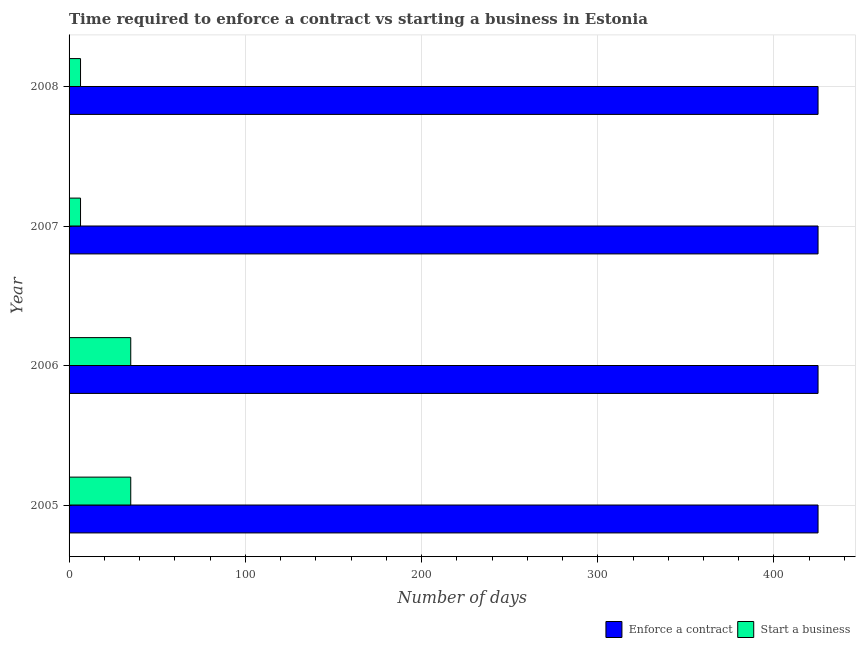How many different coloured bars are there?
Keep it short and to the point. 2. Are the number of bars per tick equal to the number of legend labels?
Make the answer very short. Yes. Are the number of bars on each tick of the Y-axis equal?
Make the answer very short. Yes. How many bars are there on the 3rd tick from the top?
Provide a succinct answer. 2. In how many cases, is the number of bars for a given year not equal to the number of legend labels?
Your response must be concise. 0. What is the number of days to enforece a contract in 2008?
Give a very brief answer. 425. Across all years, what is the maximum number of days to start a business?
Your answer should be very brief. 35. In which year was the number of days to start a business maximum?
Offer a terse response. 2005. What is the total number of days to enforece a contract in the graph?
Offer a very short reply. 1700. What is the difference between the number of days to start a business in 2007 and that in 2008?
Offer a very short reply. 0. What is the difference between the number of days to start a business in 2006 and the number of days to enforece a contract in 2005?
Give a very brief answer. -390. What is the average number of days to start a business per year?
Ensure brevity in your answer.  20.75. In the year 2005, what is the difference between the number of days to enforece a contract and number of days to start a business?
Your answer should be compact. 390. What is the ratio of the number of days to start a business in 2005 to that in 2008?
Provide a short and direct response. 5.38. In how many years, is the number of days to enforece a contract greater than the average number of days to enforece a contract taken over all years?
Give a very brief answer. 0. What does the 2nd bar from the top in 2007 represents?
Provide a short and direct response. Enforce a contract. What does the 2nd bar from the bottom in 2006 represents?
Provide a short and direct response. Start a business. How many bars are there?
Your response must be concise. 8. Are all the bars in the graph horizontal?
Offer a very short reply. Yes. How many years are there in the graph?
Your answer should be compact. 4. What is the difference between two consecutive major ticks on the X-axis?
Offer a very short reply. 100. Are the values on the major ticks of X-axis written in scientific E-notation?
Give a very brief answer. No. Does the graph contain any zero values?
Provide a succinct answer. No. Does the graph contain grids?
Your answer should be very brief. Yes. How many legend labels are there?
Your response must be concise. 2. How are the legend labels stacked?
Give a very brief answer. Horizontal. What is the title of the graph?
Your response must be concise. Time required to enforce a contract vs starting a business in Estonia. What is the label or title of the X-axis?
Provide a short and direct response. Number of days. What is the label or title of the Y-axis?
Give a very brief answer. Year. What is the Number of days of Enforce a contract in 2005?
Make the answer very short. 425. What is the Number of days of Enforce a contract in 2006?
Make the answer very short. 425. What is the Number of days in Start a business in 2006?
Keep it short and to the point. 35. What is the Number of days of Enforce a contract in 2007?
Your answer should be very brief. 425. What is the Number of days of Enforce a contract in 2008?
Your answer should be very brief. 425. What is the Number of days in Start a business in 2008?
Your response must be concise. 6.5. Across all years, what is the maximum Number of days of Enforce a contract?
Offer a terse response. 425. Across all years, what is the minimum Number of days in Enforce a contract?
Your answer should be compact. 425. Across all years, what is the minimum Number of days of Start a business?
Make the answer very short. 6.5. What is the total Number of days in Enforce a contract in the graph?
Give a very brief answer. 1700. What is the difference between the Number of days in Enforce a contract in 2005 and that in 2006?
Offer a very short reply. 0. What is the difference between the Number of days in Start a business in 2005 and that in 2006?
Offer a terse response. 0. What is the difference between the Number of days in Start a business in 2005 and that in 2007?
Ensure brevity in your answer.  28.5. What is the difference between the Number of days of Enforce a contract in 2005 and that in 2008?
Your answer should be compact. 0. What is the difference between the Number of days in Enforce a contract in 2006 and that in 2007?
Provide a succinct answer. 0. What is the difference between the Number of days of Enforce a contract in 2006 and that in 2008?
Your answer should be very brief. 0. What is the difference between the Number of days of Start a business in 2006 and that in 2008?
Your answer should be very brief. 28.5. What is the difference between the Number of days of Enforce a contract in 2007 and that in 2008?
Make the answer very short. 0. What is the difference between the Number of days of Start a business in 2007 and that in 2008?
Your response must be concise. 0. What is the difference between the Number of days in Enforce a contract in 2005 and the Number of days in Start a business in 2006?
Your answer should be compact. 390. What is the difference between the Number of days in Enforce a contract in 2005 and the Number of days in Start a business in 2007?
Keep it short and to the point. 418.5. What is the difference between the Number of days in Enforce a contract in 2005 and the Number of days in Start a business in 2008?
Your response must be concise. 418.5. What is the difference between the Number of days in Enforce a contract in 2006 and the Number of days in Start a business in 2007?
Ensure brevity in your answer.  418.5. What is the difference between the Number of days of Enforce a contract in 2006 and the Number of days of Start a business in 2008?
Provide a succinct answer. 418.5. What is the difference between the Number of days of Enforce a contract in 2007 and the Number of days of Start a business in 2008?
Your answer should be very brief. 418.5. What is the average Number of days in Enforce a contract per year?
Your response must be concise. 425. What is the average Number of days of Start a business per year?
Your answer should be compact. 20.75. In the year 2005, what is the difference between the Number of days of Enforce a contract and Number of days of Start a business?
Offer a terse response. 390. In the year 2006, what is the difference between the Number of days of Enforce a contract and Number of days of Start a business?
Provide a short and direct response. 390. In the year 2007, what is the difference between the Number of days of Enforce a contract and Number of days of Start a business?
Keep it short and to the point. 418.5. In the year 2008, what is the difference between the Number of days of Enforce a contract and Number of days of Start a business?
Offer a terse response. 418.5. What is the ratio of the Number of days in Start a business in 2005 to that in 2006?
Your response must be concise. 1. What is the ratio of the Number of days in Enforce a contract in 2005 to that in 2007?
Your answer should be compact. 1. What is the ratio of the Number of days of Start a business in 2005 to that in 2007?
Offer a very short reply. 5.38. What is the ratio of the Number of days of Enforce a contract in 2005 to that in 2008?
Provide a short and direct response. 1. What is the ratio of the Number of days of Start a business in 2005 to that in 2008?
Your response must be concise. 5.38. What is the ratio of the Number of days of Enforce a contract in 2006 to that in 2007?
Your response must be concise. 1. What is the ratio of the Number of days of Start a business in 2006 to that in 2007?
Offer a very short reply. 5.38. What is the ratio of the Number of days of Enforce a contract in 2006 to that in 2008?
Make the answer very short. 1. What is the ratio of the Number of days of Start a business in 2006 to that in 2008?
Your response must be concise. 5.38. What is the ratio of the Number of days in Enforce a contract in 2007 to that in 2008?
Offer a terse response. 1. What is the difference between the highest and the second highest Number of days in Enforce a contract?
Make the answer very short. 0. What is the difference between the highest and the second highest Number of days in Start a business?
Provide a succinct answer. 0. What is the difference between the highest and the lowest Number of days of Enforce a contract?
Offer a terse response. 0. What is the difference between the highest and the lowest Number of days in Start a business?
Your response must be concise. 28.5. 